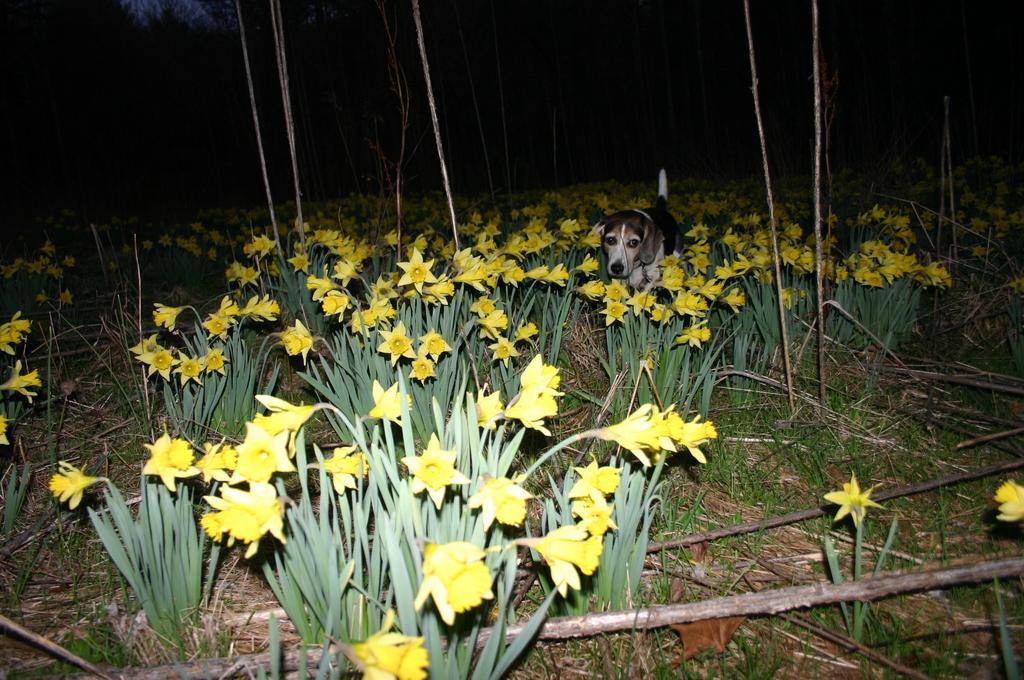What type of living organisms can be seen in the image? Plants are visible in the image. What color are the flowers on the plants? There are yellow flowers in the image. What is located in the center of the image? There is a dog in the center of the image. What type of vegetation is at the bottom of the image? There is grass at the bottom of the image. What is the reason for the railway crossing the road in the image? There is no railway or road present in the image; it features plants, yellow flowers, and a dog. 